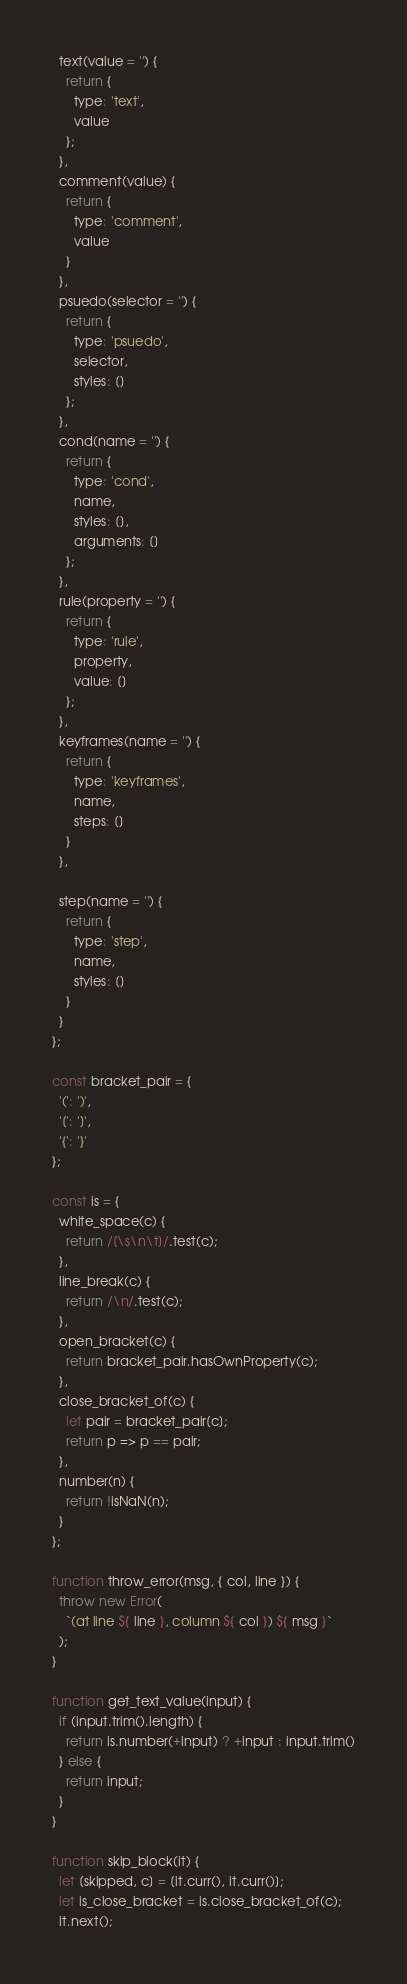Convert code to text. <code><loc_0><loc_0><loc_500><loc_500><_JavaScript_>  text(value = '') {
    return {
      type: 'text',
      value
    };
  },
  comment(value) {
    return {
      type: 'comment',
      value
    }
  },
  psuedo(selector = '') {
    return {
      type: 'psuedo',
      selector,
      styles: []
    };
  },
  cond(name = '') {
    return {
      type: 'cond',
      name,
      styles: [],
      arguments: []
    };
  },
  rule(property = '') {
    return {
      type: 'rule',
      property,
      value: []
    };
  },
  keyframes(name = '') {
    return {
      type: 'keyframes',
      name,
      steps: []
    }
  },

  step(name = '') {
    return {
      type: 'step',
      name,
      styles: []
    }
  }
};

const bracket_pair = {
  '(': ')',
  '[': ']',
  '{': '}'
};

const is = {
  white_space(c) {
    return /[\s\n\t]/.test(c);
  },
  line_break(c) {
    return /\n/.test(c);
  },
  open_bracket(c) {
    return bracket_pair.hasOwnProperty(c);
  },
  close_bracket_of(c) {
    let pair = bracket_pair[c];
    return p => p == pair;
  },
  number(n) {
    return !isNaN(n);
  }
};

function throw_error(msg, { col, line }) {
  throw new Error(
    `(at line ${ line }, column ${ col }) ${ msg }`
  );
}

function get_text_value(input) {
  if (input.trim().length) {
    return is.number(+input) ? +input : input.trim()
  } else {
    return input;
  }
}

function skip_block(it) {
  let [skipped, c] = [it.curr(), it.curr()];
  let is_close_bracket = is.close_bracket_of(c);
  it.next();</code> 